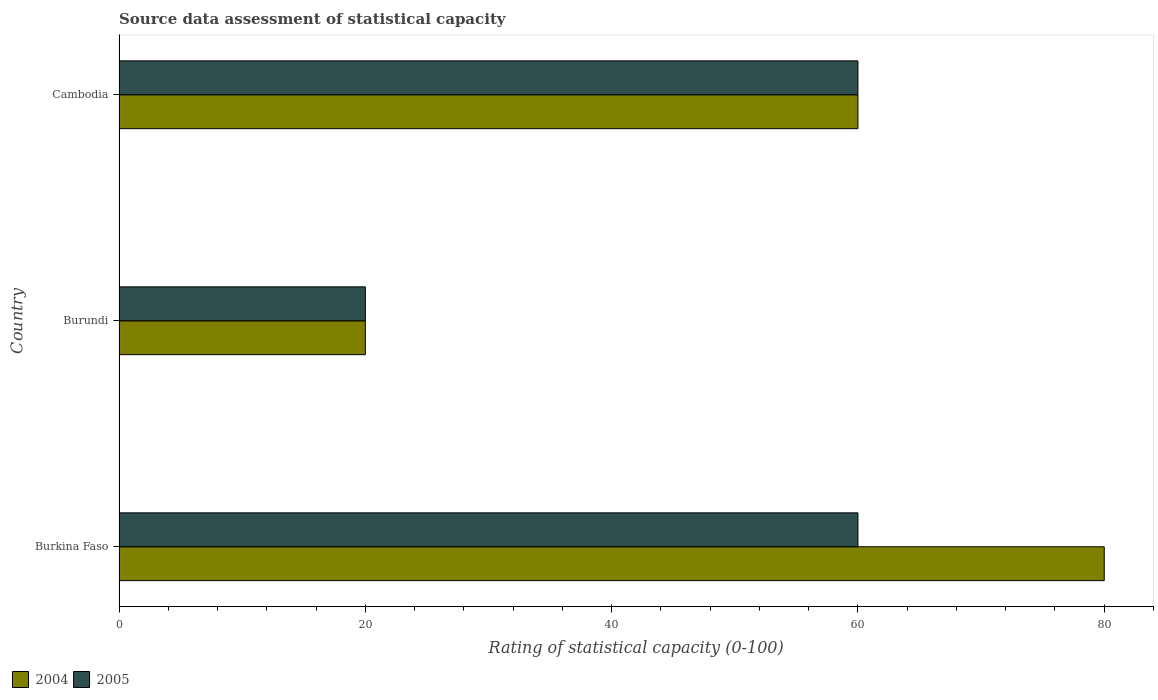How many groups of bars are there?
Offer a very short reply. 3. Are the number of bars per tick equal to the number of legend labels?
Make the answer very short. Yes. What is the label of the 2nd group of bars from the top?
Your answer should be very brief. Burundi. What is the rating of statistical capacity in 2004 in Cambodia?
Offer a very short reply. 60. In which country was the rating of statistical capacity in 2005 maximum?
Your response must be concise. Burkina Faso. In which country was the rating of statistical capacity in 2004 minimum?
Offer a very short reply. Burundi. What is the total rating of statistical capacity in 2005 in the graph?
Provide a short and direct response. 140. What is the difference between the rating of statistical capacity in 2005 in Burundi and that in Cambodia?
Offer a terse response. -40. What is the average rating of statistical capacity in 2004 per country?
Ensure brevity in your answer.  53.33. In how many countries, is the rating of statistical capacity in 2005 greater than 40 ?
Offer a terse response. 2. What is the ratio of the rating of statistical capacity in 2005 in Burundi to that in Cambodia?
Give a very brief answer. 0.33. Is the difference between the rating of statistical capacity in 2005 in Burkina Faso and Cambodia greater than the difference between the rating of statistical capacity in 2004 in Burkina Faso and Cambodia?
Provide a short and direct response. No. What is the difference between the highest and the second highest rating of statistical capacity in 2004?
Your answer should be compact. 20. What is the difference between the highest and the lowest rating of statistical capacity in 2005?
Your answer should be compact. 40. What does the 2nd bar from the top in Cambodia represents?
Provide a short and direct response. 2004. Are all the bars in the graph horizontal?
Keep it short and to the point. Yes. How many countries are there in the graph?
Ensure brevity in your answer.  3. Does the graph contain any zero values?
Keep it short and to the point. No. Does the graph contain grids?
Offer a terse response. No. Where does the legend appear in the graph?
Give a very brief answer. Bottom left. What is the title of the graph?
Offer a very short reply. Source data assessment of statistical capacity. What is the label or title of the X-axis?
Offer a terse response. Rating of statistical capacity (0-100). What is the label or title of the Y-axis?
Offer a very short reply. Country. What is the Rating of statistical capacity (0-100) in 2005 in Burkina Faso?
Your answer should be compact. 60. What is the Rating of statistical capacity (0-100) in 2005 in Burundi?
Offer a terse response. 20. Across all countries, what is the maximum Rating of statistical capacity (0-100) of 2004?
Make the answer very short. 80. Across all countries, what is the maximum Rating of statistical capacity (0-100) of 2005?
Your answer should be compact. 60. Across all countries, what is the minimum Rating of statistical capacity (0-100) of 2005?
Offer a very short reply. 20. What is the total Rating of statistical capacity (0-100) of 2004 in the graph?
Provide a succinct answer. 160. What is the total Rating of statistical capacity (0-100) of 2005 in the graph?
Give a very brief answer. 140. What is the difference between the Rating of statistical capacity (0-100) in 2005 in Burundi and that in Cambodia?
Your answer should be very brief. -40. What is the difference between the Rating of statistical capacity (0-100) in 2004 in Burkina Faso and the Rating of statistical capacity (0-100) in 2005 in Burundi?
Keep it short and to the point. 60. What is the difference between the Rating of statistical capacity (0-100) in 2004 in Burundi and the Rating of statistical capacity (0-100) in 2005 in Cambodia?
Offer a very short reply. -40. What is the average Rating of statistical capacity (0-100) in 2004 per country?
Provide a succinct answer. 53.33. What is the average Rating of statistical capacity (0-100) of 2005 per country?
Your answer should be compact. 46.67. What is the difference between the Rating of statistical capacity (0-100) in 2004 and Rating of statistical capacity (0-100) in 2005 in Cambodia?
Your answer should be very brief. 0. What is the ratio of the Rating of statistical capacity (0-100) of 2004 in Burkina Faso to that in Burundi?
Keep it short and to the point. 4. What is the ratio of the Rating of statistical capacity (0-100) of 2005 in Burkina Faso to that in Burundi?
Ensure brevity in your answer.  3. What is the difference between the highest and the second highest Rating of statistical capacity (0-100) in 2004?
Your answer should be very brief. 20. What is the difference between the highest and the lowest Rating of statistical capacity (0-100) in 2004?
Provide a succinct answer. 60. What is the difference between the highest and the lowest Rating of statistical capacity (0-100) in 2005?
Offer a terse response. 40. 